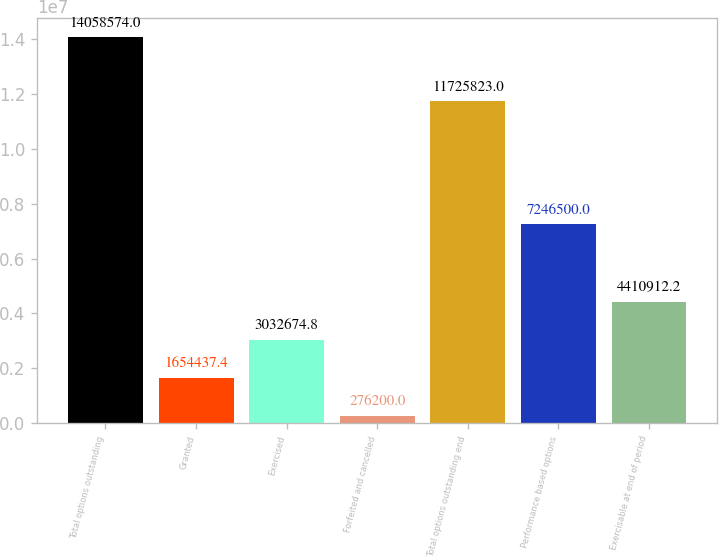Convert chart. <chart><loc_0><loc_0><loc_500><loc_500><bar_chart><fcel>Total options outstanding<fcel>Granted<fcel>Exercised<fcel>Forfeited and cancelled<fcel>Total options outstanding end<fcel>Performance based options<fcel>Exercisable at end of period<nl><fcel>1.40586e+07<fcel>1.65444e+06<fcel>3.03267e+06<fcel>276200<fcel>1.17258e+07<fcel>7.2465e+06<fcel>4.41091e+06<nl></chart> 